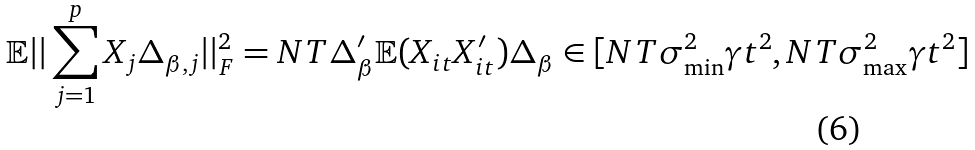<formula> <loc_0><loc_0><loc_500><loc_500>\mathbb { E } | | \sum _ { j = 1 } ^ { p } X _ { j } \Delta _ { \beta , j } | | _ { F } ^ { 2 } = N T \Delta _ { \beta } ^ { \prime } \mathbb { E } ( X _ { i t } X _ { i t } ^ { \prime } ) \Delta _ { \beta } \in [ N T \sigma ^ { 2 } _ { \min } \gamma t ^ { 2 } , N T \sigma ^ { 2 } _ { \max } \gamma t ^ { 2 } ]</formula> 